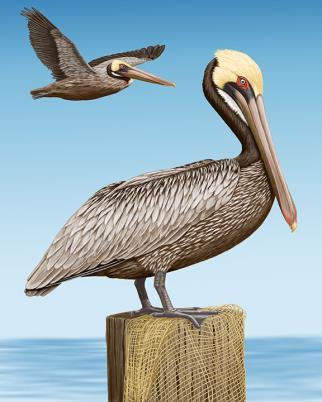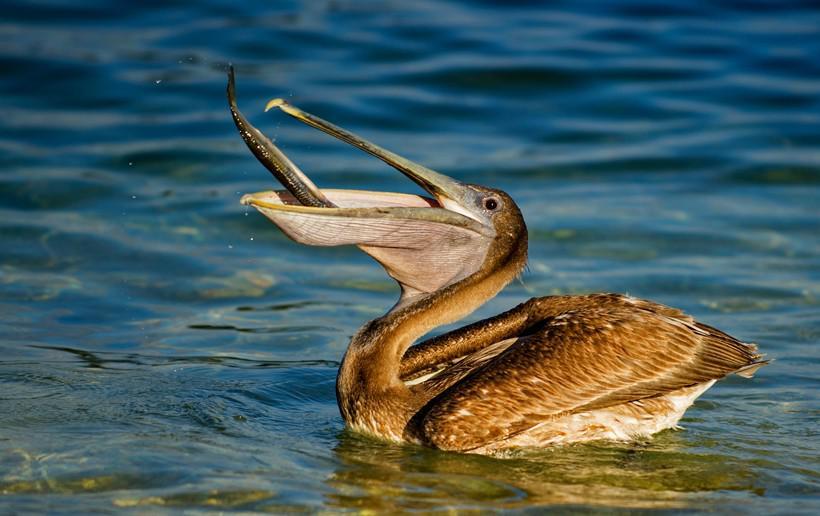The first image is the image on the left, the second image is the image on the right. Evaluate the accuracy of this statement regarding the images: "One image shows three pelicans on the edge of a pier.". Is it true? Answer yes or no. No. The first image is the image on the left, the second image is the image on the right. Evaluate the accuracy of this statement regarding the images: "There are no more than three pelicans". Is it true? Answer yes or no. Yes. 